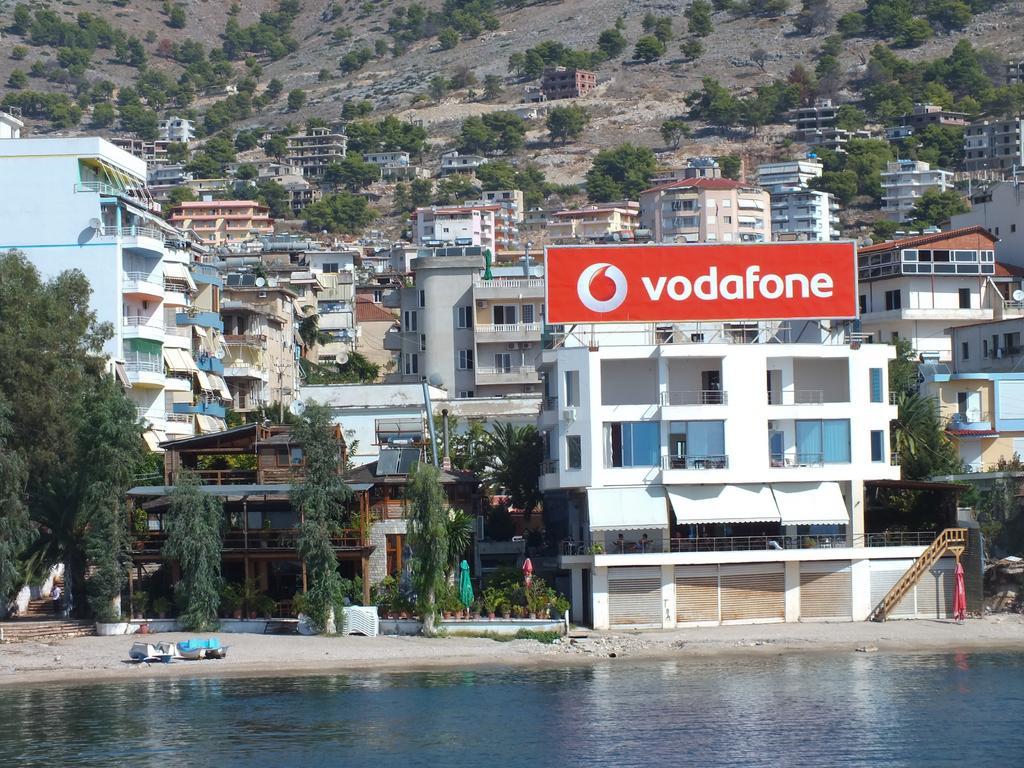Can you describe this image briefly? In this picture we can see trees, buildings with windows, water, boats on the ground, house plants, hoarding. 